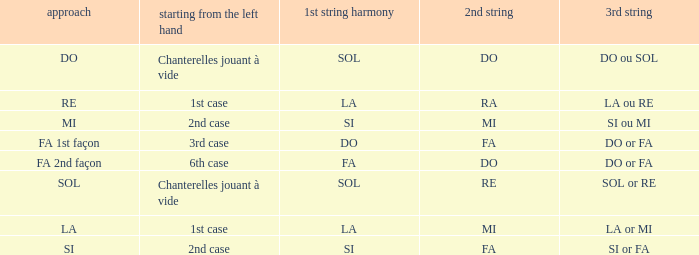For a 1st string of si Accord du and a 2nd string of mi what is the 3rd string? SI ou MI. Parse the table in full. {'header': ['approach', 'starting from the left hand', '1st string harmony', '2nd string', '3rd string'], 'rows': [['DO', 'Chanterelles jouant à vide', 'SOL', 'DO', 'DO ou SOL'], ['RE', '1st case', 'LA', 'RA', 'LA ou RE'], ['MI', '2nd case', 'SI', 'MI', 'SI ou MI'], ['FA 1st façon', '3rd case', 'DO', 'FA', 'DO or FA'], ['FA 2nd façon', '6th case', 'FA', 'DO', 'DO or FA'], ['SOL', 'Chanterelles jouant à vide', 'SOL', 'RE', 'SOL or RE'], ['LA', '1st case', 'LA', 'MI', 'LA or MI'], ['SI', '2nd case', 'SI', 'FA', 'SI or FA']]} 